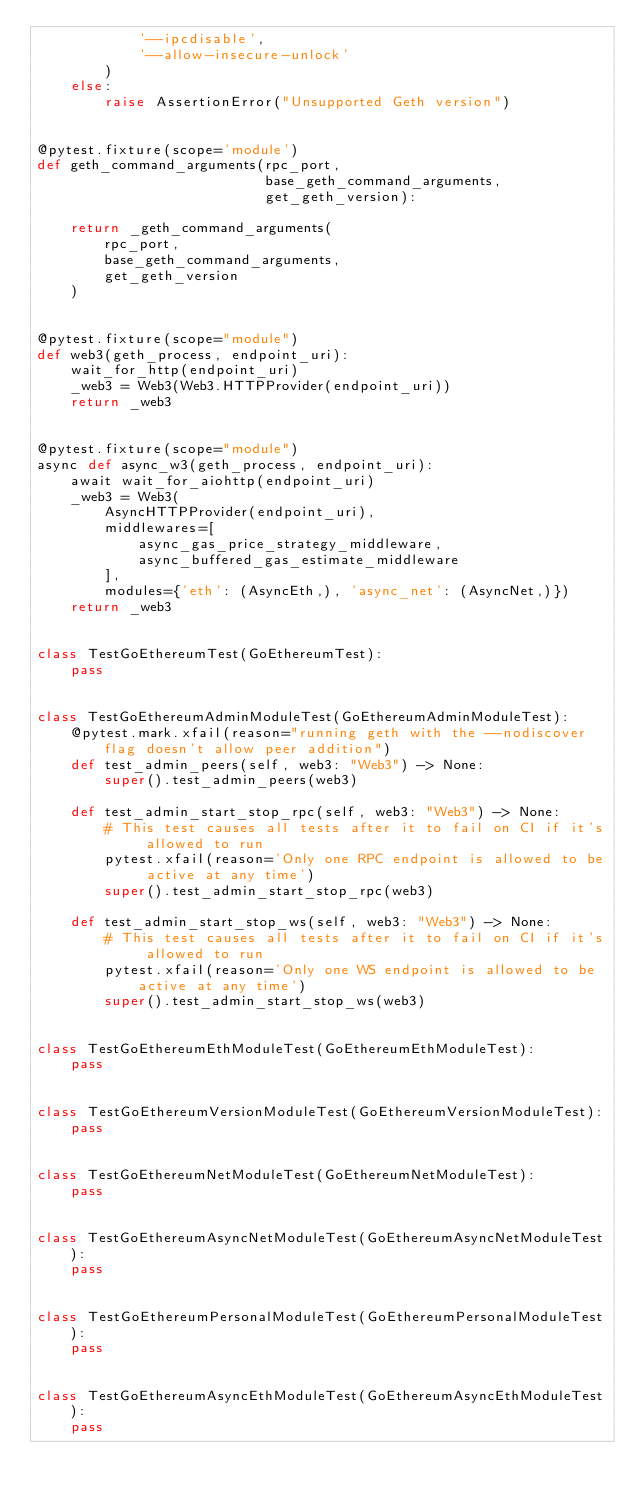<code> <loc_0><loc_0><loc_500><loc_500><_Python_>            '--ipcdisable',
            '--allow-insecure-unlock'
        )
    else:
        raise AssertionError("Unsupported Geth version")


@pytest.fixture(scope='module')
def geth_command_arguments(rpc_port,
                           base_geth_command_arguments,
                           get_geth_version):

    return _geth_command_arguments(
        rpc_port,
        base_geth_command_arguments,
        get_geth_version
    )


@pytest.fixture(scope="module")
def web3(geth_process, endpoint_uri):
    wait_for_http(endpoint_uri)
    _web3 = Web3(Web3.HTTPProvider(endpoint_uri))
    return _web3


@pytest.fixture(scope="module")
async def async_w3(geth_process, endpoint_uri):
    await wait_for_aiohttp(endpoint_uri)
    _web3 = Web3(
        AsyncHTTPProvider(endpoint_uri),
        middlewares=[
            async_gas_price_strategy_middleware,
            async_buffered_gas_estimate_middleware
        ],
        modules={'eth': (AsyncEth,), 'async_net': (AsyncNet,)})
    return _web3


class TestGoEthereumTest(GoEthereumTest):
    pass


class TestGoEthereumAdminModuleTest(GoEthereumAdminModuleTest):
    @pytest.mark.xfail(reason="running geth with the --nodiscover flag doesn't allow peer addition")
    def test_admin_peers(self, web3: "Web3") -> None:
        super().test_admin_peers(web3)

    def test_admin_start_stop_rpc(self, web3: "Web3") -> None:
        # This test causes all tests after it to fail on CI if it's allowed to run
        pytest.xfail(reason='Only one RPC endpoint is allowed to be active at any time')
        super().test_admin_start_stop_rpc(web3)

    def test_admin_start_stop_ws(self, web3: "Web3") -> None:
        # This test causes all tests after it to fail on CI if it's allowed to run
        pytest.xfail(reason='Only one WS endpoint is allowed to be active at any time')
        super().test_admin_start_stop_ws(web3)


class TestGoEthereumEthModuleTest(GoEthereumEthModuleTest):
    pass


class TestGoEthereumVersionModuleTest(GoEthereumVersionModuleTest):
    pass


class TestGoEthereumNetModuleTest(GoEthereumNetModuleTest):
    pass


class TestGoEthereumAsyncNetModuleTest(GoEthereumAsyncNetModuleTest):
    pass


class TestGoEthereumPersonalModuleTest(GoEthereumPersonalModuleTest):
    pass


class TestGoEthereumAsyncEthModuleTest(GoEthereumAsyncEthModuleTest):
    pass
</code> 